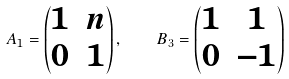Convert formula to latex. <formula><loc_0><loc_0><loc_500><loc_500>A _ { 1 } = \begin{pmatrix} 1 & n \\ 0 & 1 \end{pmatrix} , \quad B _ { 3 } = \begin{pmatrix} 1 & 1 \\ 0 & - 1 \end{pmatrix}</formula> 